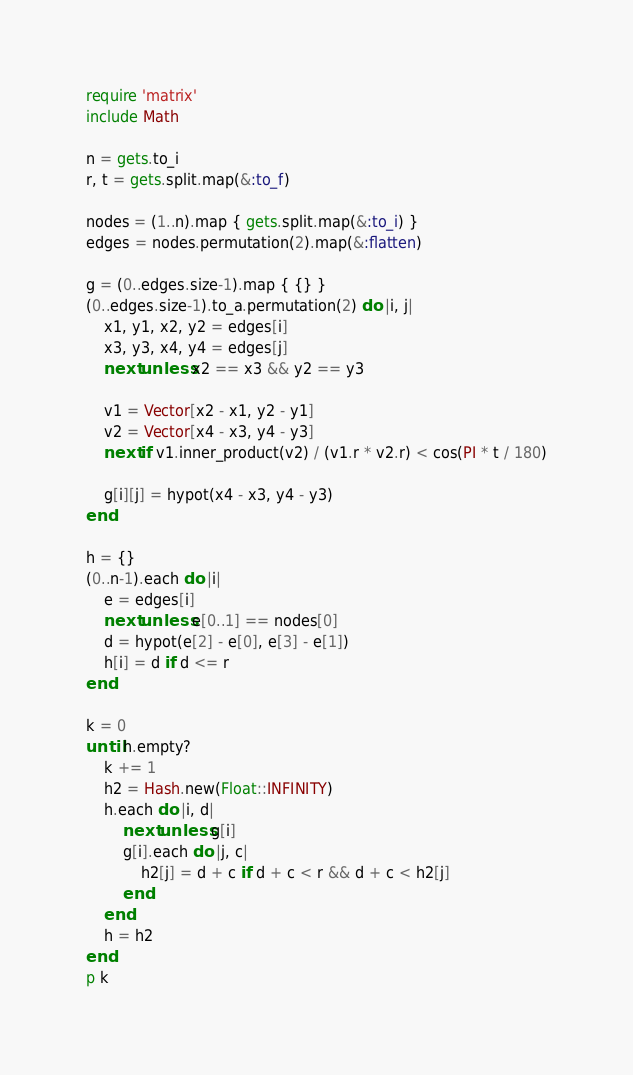Convert code to text. <code><loc_0><loc_0><loc_500><loc_500><_Ruby_>require 'matrix'
include Math

n = gets.to_i
r, t = gets.split.map(&:to_f)

nodes = (1..n).map { gets.split.map(&:to_i) }
edges = nodes.permutation(2).map(&:flatten)

g = (0..edges.size-1).map { {} }
(0..edges.size-1).to_a.permutation(2) do |i, j|
    x1, y1, x2, y2 = edges[i]
    x3, y3, x4, y4 = edges[j]
    next unless x2 == x3 && y2 == y3

    v1 = Vector[x2 - x1, y2 - y1]
    v2 = Vector[x4 - x3, y4 - y3]
    next if v1.inner_product(v2) / (v1.r * v2.r) < cos(PI * t / 180)

    g[i][j] = hypot(x4 - x3, y4 - y3)
end

h = {}
(0..n-1).each do |i|
    e = edges[i]
    next unless e[0..1] == nodes[0]
    d = hypot(e[2] - e[0], e[3] - e[1])
    h[i] = d if d <= r
end

k = 0
until h.empty?
    k += 1
    h2 = Hash.new(Float::INFINITY)
    h.each do |i, d|
        next unless g[i]
        g[i].each do |j, c|
            h2[j] = d + c if d + c < r && d + c < h2[j]
        end
    end
    h = h2
end
p k</code> 